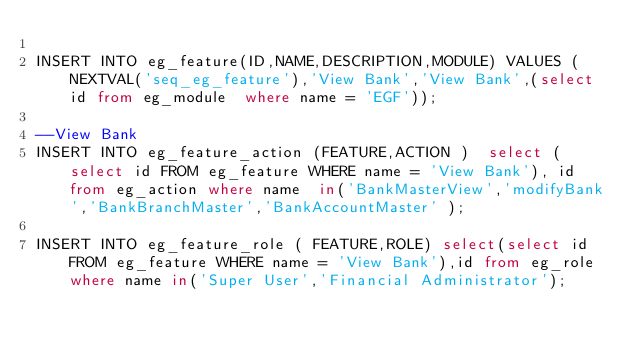Convert code to text. <code><loc_0><loc_0><loc_500><loc_500><_SQL_>
INSERT INTO eg_feature(ID,NAME,DESCRIPTION,MODULE) VALUES (NEXTVAL('seq_eg_feature'),'View Bank','View Bank',(select id from eg_module  where name = 'EGF'));

--View Bank
INSERT INTO eg_feature_action (FEATURE,ACTION )  select (select id FROM eg_feature WHERE name = 'View Bank'), id from eg_action where name  in('BankMasterView','modifyBank','BankBranchMaster','BankAccountMaster' );

INSERT INTO eg_feature_role ( FEATURE,ROLE) select(select id FROM eg_feature WHERE name = 'View Bank'),id from eg_role where name in('Super User','Financial Administrator');
</code> 